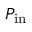Convert formula to latex. <formula><loc_0><loc_0><loc_500><loc_500>P _ { i n }</formula> 